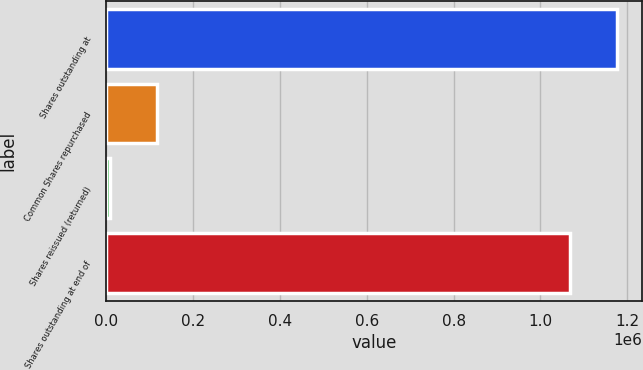Convert chart to OTSL. <chart><loc_0><loc_0><loc_500><loc_500><bar_chart><fcel>Shares outstanding at<fcel>Common Shares repurchased<fcel>Shares reissued (returned)<fcel>Shares outstanding at end of<nl><fcel>1.17613e+06<fcel>115907<fcel>8862<fcel>1.06908e+06<nl></chart> 